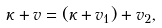<formula> <loc_0><loc_0><loc_500><loc_500>\kappa + v = ( \kappa + v _ { 1 } ) + v _ { 2 } ,</formula> 